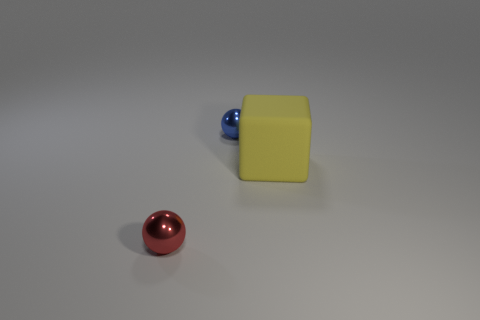Add 1 small gray balls. How many objects exist? 4 Subtract all spheres. How many objects are left? 1 Subtract 0 purple blocks. How many objects are left? 3 Subtract all large cyan cylinders. Subtract all big matte objects. How many objects are left? 2 Add 1 red balls. How many red balls are left? 2 Add 2 small green shiny cubes. How many small green shiny cubes exist? 2 